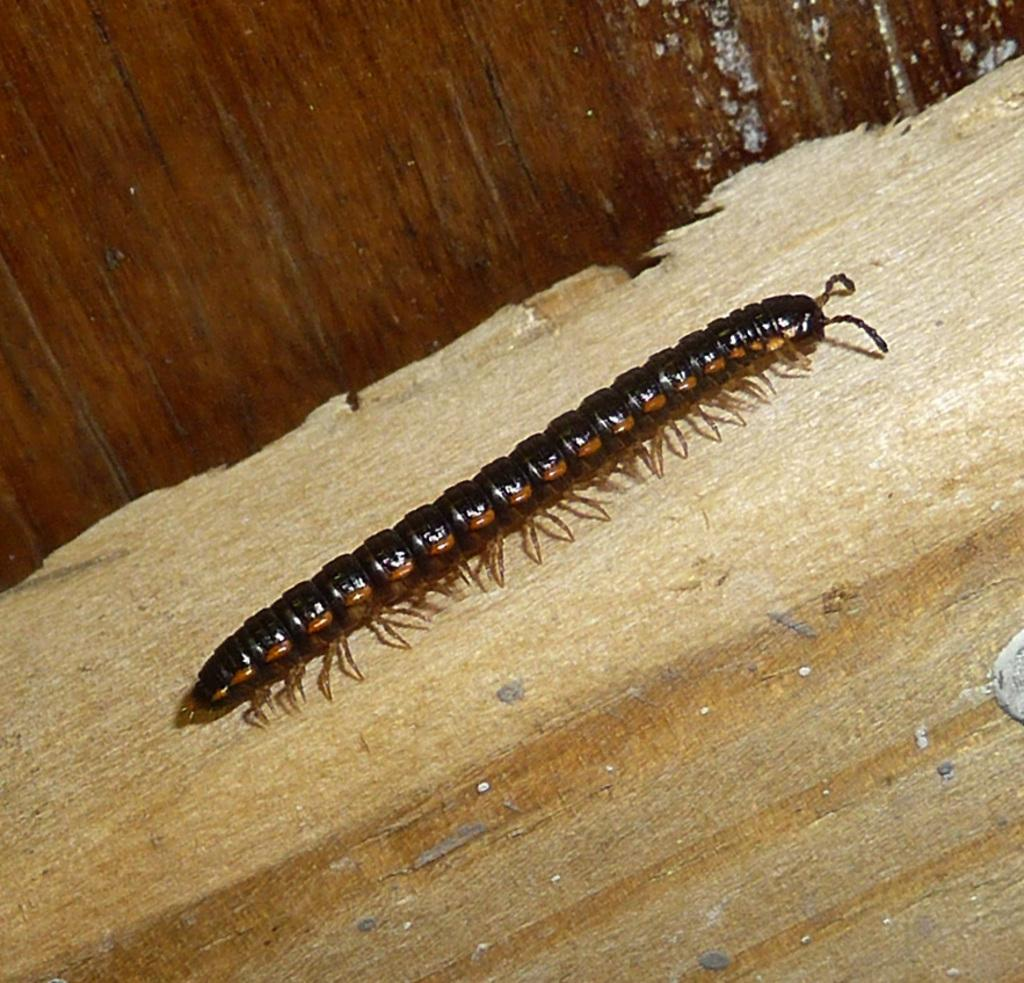What is the main object in the center of the image? There is a piece of wood in the center of the image. What is on the piece of wood? There is an insect on the wood. What color is the insect? The insect is black in color. What can be seen in the background of the image? There is a wooden wall in the background of the image. What story does the insect tell in the image? There is no story being told by the insect in the image; it is simply an insect on a piece of wood. 